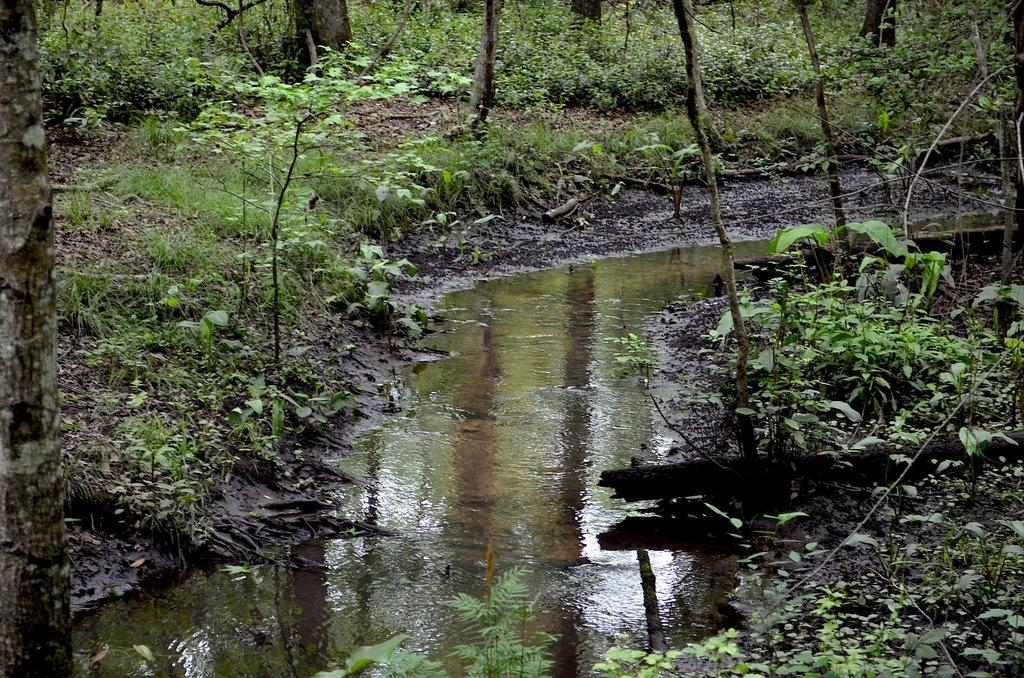What is the primary element visible in the image? There is water in the image. What type of vegetation can be seen in the image? There are plants in the image. What else is present in the image besides water and plants? There are branches in the image. How many cows can be seen grazing in the image? There are no cows present in the image. What type of dolls are placed among the plants in the image? There are no dolls present in the image. 